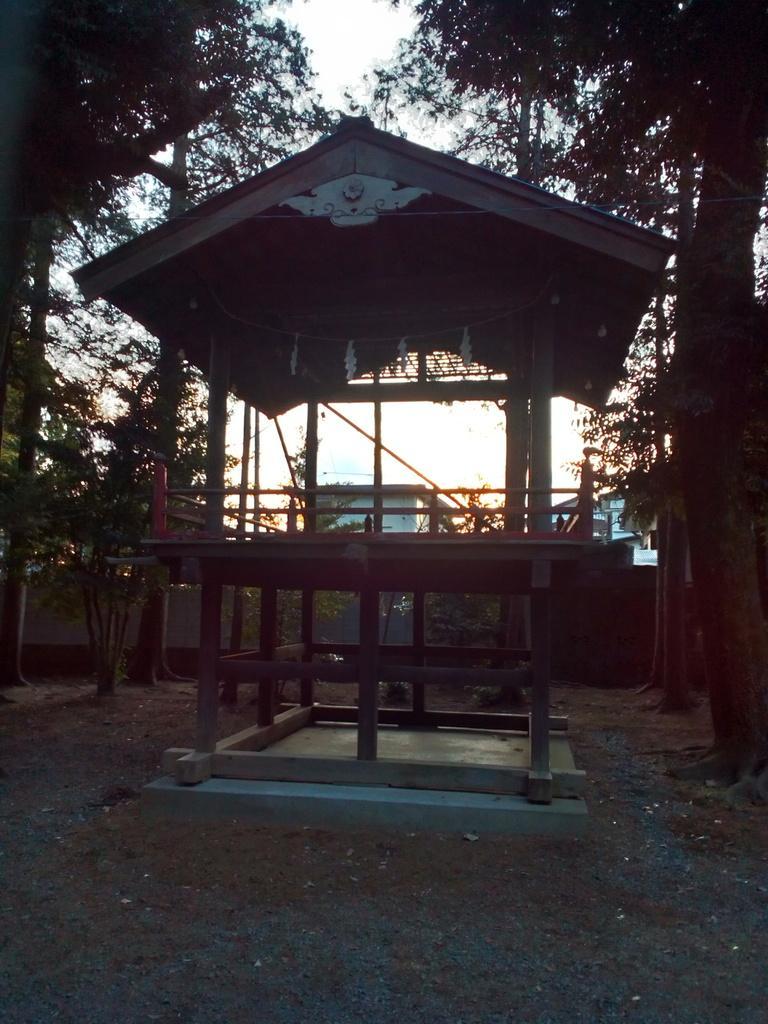Could you give a brief overview of what you see in this image? In the foreground of this image, there is a shed and the ground on the bottom. In the background, there are trees and the sky. 